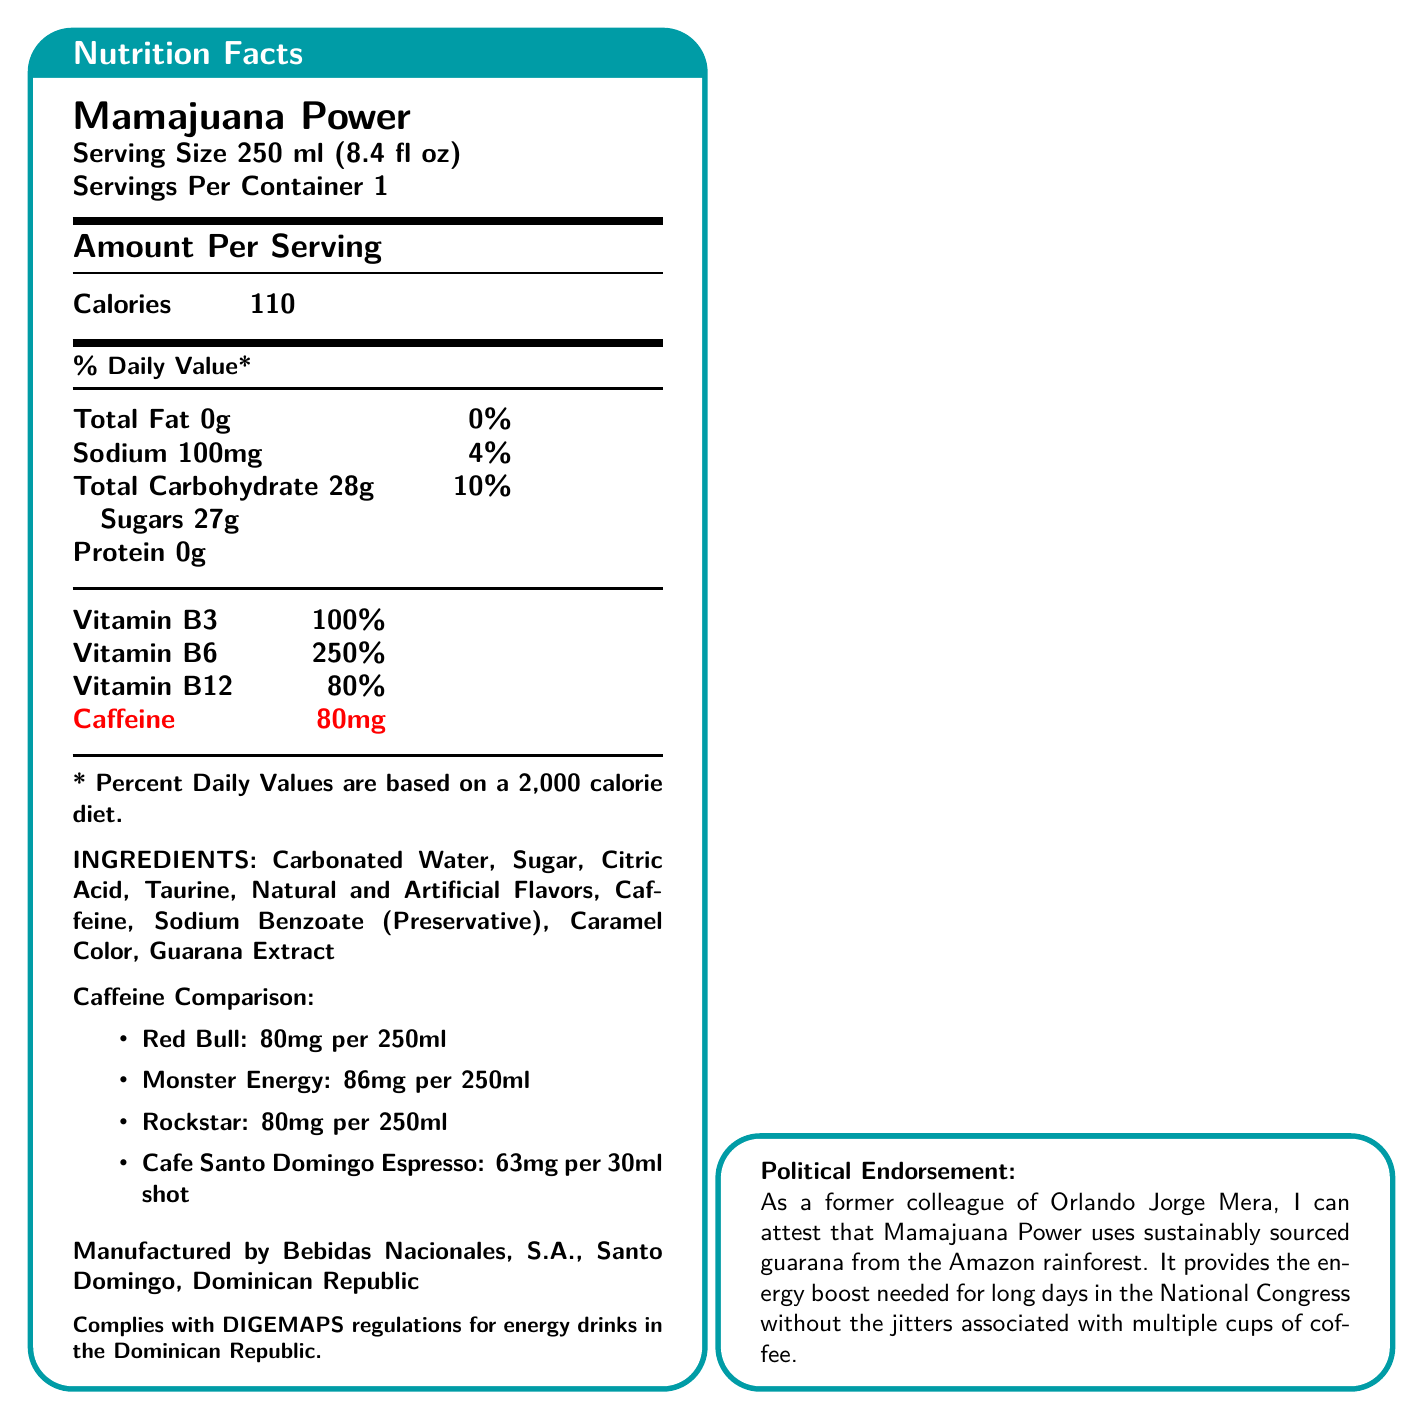what is the caffeine content in Mamajuana Power? The document states under the "Amount Per Serving" section that Mamajuana Power contains 80mg of caffeine per 250ml serving.
Answer: 80mg How many calories are in one serving of Mamajuana Power? The document indicates in the "Amount Per Serving" section that each serving of Mamajuana Power has 110 calories.
Answer: 110 calories What percentage of Vitamin B6 does Mamajuana Power contain per serving? According to the tabular section in the document, Mamajuana Power contains 250% of the daily value for Vitamin B6.
Answer: 250% DV What is the serving size of Mamajuana Power? The serving size is clearly stated at the beginning of the nutrition facts: 250 ml (8.4 fl oz).
Answer: 250 ml (8.4 fl oz) What are the main ingredients in Mamajuana Power? The document lists these ingredients under the "INGREDIENTS" section.
Answer: Carbonated Water, Sugar, Citric Acid, Taurine, Natural and Artificial Flavors, Caffeine, Sodium Benzoate (Preservative), Caramel Color, Guarana Extract Which brand has the highest caffeine content when compared to Mamajuana Power? A. Red Bull B. Monster Energy C. Rockstar The document lists Monster Energy as containing 86mg of caffeine per 250ml, higher than Mamajuana Power's 80mg.
Answer: B. Monster Energy What is the caffeine content in Red Bull for a 250ml serving? A. 63mg B. 80mg C. 86mg According to the "Caffeine Comparison" section, Red Bull has 80mg of caffeine per 250ml serving.
Answer: B. 80mg Is the ingredient guarana extract sustainably sourced? (Yes/No) The document's marketing claim explicitly notes that the guarana is sustainably sourced from the Amazon rainforest.
Answer: Yes Describe the general purpose and contents of the Mamajuana Power Nutrition Facts document. This summary covers the primary sections and emphasizes the focus on nutrition facts, ingredients, and the political and environmental claims associated with the product.
Answer: Mamajuana Power is a Dominican energy drink with a serving size of 250ml that contains 80mg of caffeine, 110 calories, various vitamins, and sustainably sourced guarana. The document provides nutritional information, ingredients, a caffeine comparison chart, regulatory compliance, and a political endorsement for environmentally friendly practices and effectiveness. Where is Bebidas Nacionales, S.A. located? The document states that the manufacturer, Bebidas Nacionales, S.A., is located in Santo Domingo, Dominican Republic.
Answer: Santo Domingo, Dominican Republic Can this document confirm whether Mamajuana Power is available internationally? The document provides nutritional information, regulatory compliance, and environmental claims but does not specify the product's availability in international markets.
Answer: Cannot be determined 